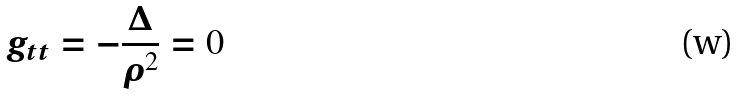Convert formula to latex. <formula><loc_0><loc_0><loc_500><loc_500>g _ { t t } = - \frac { \Delta } { \rho ^ { 2 } } = 0</formula> 